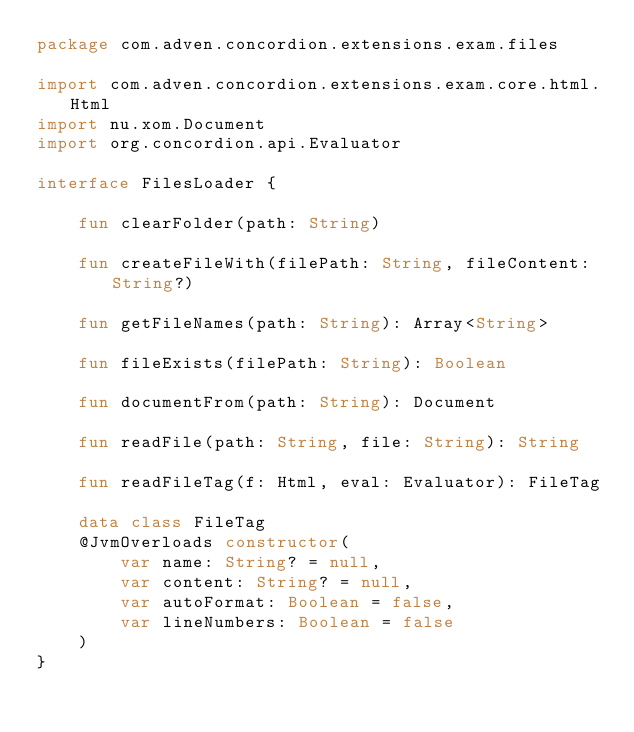<code> <loc_0><loc_0><loc_500><loc_500><_Kotlin_>package com.adven.concordion.extensions.exam.files

import com.adven.concordion.extensions.exam.core.html.Html
import nu.xom.Document
import org.concordion.api.Evaluator

interface FilesLoader {

    fun clearFolder(path: String)

    fun createFileWith(filePath: String, fileContent: String?)

    fun getFileNames(path: String): Array<String>

    fun fileExists(filePath: String): Boolean

    fun documentFrom(path: String): Document

    fun readFile(path: String, file: String): String

    fun readFileTag(f: Html, eval: Evaluator): FileTag

    data class FileTag
    @JvmOverloads constructor(
        var name: String? = null,
        var content: String? = null,
        var autoFormat: Boolean = false,
        var lineNumbers: Boolean = false
    )
}</code> 